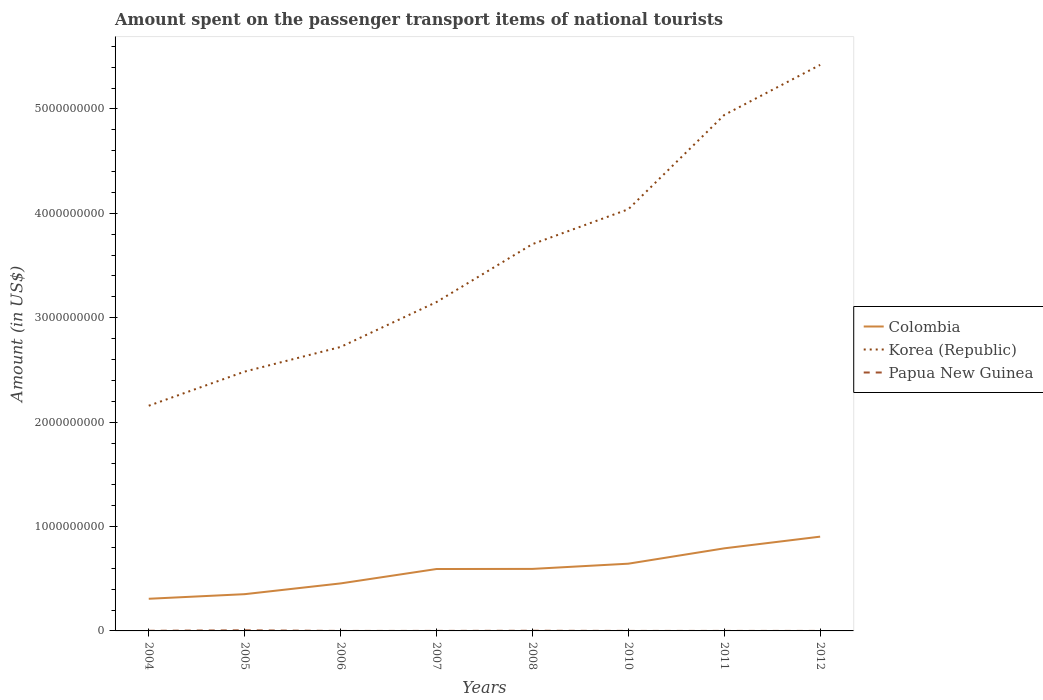How many different coloured lines are there?
Offer a terse response. 3. Is the number of lines equal to the number of legend labels?
Make the answer very short. Yes. Across all years, what is the maximum amount spent on the passenger transport items of national tourists in Korea (Republic)?
Provide a short and direct response. 2.16e+09. What is the total amount spent on the passenger transport items of national tourists in Korea (Republic) in the graph?
Make the answer very short. -1.32e+09. What is the difference between the highest and the second highest amount spent on the passenger transport items of national tourists in Colombia?
Make the answer very short. 5.95e+08. Is the amount spent on the passenger transport items of national tourists in Colombia strictly greater than the amount spent on the passenger transport items of national tourists in Korea (Republic) over the years?
Your answer should be compact. Yes. How many lines are there?
Give a very brief answer. 3. How many years are there in the graph?
Offer a very short reply. 8. What is the difference between two consecutive major ticks on the Y-axis?
Your answer should be compact. 1.00e+09. Are the values on the major ticks of Y-axis written in scientific E-notation?
Provide a succinct answer. No. How are the legend labels stacked?
Offer a terse response. Vertical. What is the title of the graph?
Offer a terse response. Amount spent on the passenger transport items of national tourists. Does "Comoros" appear as one of the legend labels in the graph?
Your answer should be very brief. No. What is the label or title of the X-axis?
Your answer should be compact. Years. What is the Amount (in US$) in Colombia in 2004?
Your answer should be very brief. 3.08e+08. What is the Amount (in US$) of Korea (Republic) in 2004?
Your answer should be compact. 2.16e+09. What is the Amount (in US$) in Papua New Guinea in 2004?
Provide a short and direct response. 1.30e+06. What is the Amount (in US$) in Colombia in 2005?
Keep it short and to the point. 3.52e+08. What is the Amount (in US$) of Korea (Republic) in 2005?
Offer a very short reply. 2.48e+09. What is the Amount (in US$) of Papua New Guinea in 2005?
Keep it short and to the point. 5.80e+06. What is the Amount (in US$) in Colombia in 2006?
Your response must be concise. 4.55e+08. What is the Amount (in US$) of Korea (Republic) in 2006?
Ensure brevity in your answer.  2.72e+09. What is the Amount (in US$) in Colombia in 2007?
Offer a very short reply. 5.93e+08. What is the Amount (in US$) of Korea (Republic) in 2007?
Your answer should be very brief. 3.15e+09. What is the Amount (in US$) of Colombia in 2008?
Your answer should be very brief. 5.94e+08. What is the Amount (in US$) of Korea (Republic) in 2008?
Ensure brevity in your answer.  3.70e+09. What is the Amount (in US$) of Papua New Guinea in 2008?
Provide a succinct answer. 1.60e+06. What is the Amount (in US$) of Colombia in 2010?
Offer a terse response. 6.44e+08. What is the Amount (in US$) of Korea (Republic) in 2010?
Keep it short and to the point. 4.04e+09. What is the Amount (in US$) of Colombia in 2011?
Keep it short and to the point. 7.91e+08. What is the Amount (in US$) in Korea (Republic) in 2011?
Your answer should be very brief. 4.94e+09. What is the Amount (in US$) in Colombia in 2012?
Offer a very short reply. 9.03e+08. What is the Amount (in US$) of Korea (Republic) in 2012?
Make the answer very short. 5.42e+09. What is the Amount (in US$) in Papua New Guinea in 2012?
Offer a terse response. 1.00e+05. Across all years, what is the maximum Amount (in US$) of Colombia?
Offer a terse response. 9.03e+08. Across all years, what is the maximum Amount (in US$) of Korea (Republic)?
Your response must be concise. 5.42e+09. Across all years, what is the maximum Amount (in US$) in Papua New Guinea?
Your answer should be compact. 5.80e+06. Across all years, what is the minimum Amount (in US$) of Colombia?
Make the answer very short. 3.08e+08. Across all years, what is the minimum Amount (in US$) of Korea (Republic)?
Provide a succinct answer. 2.16e+09. Across all years, what is the minimum Amount (in US$) of Papua New Guinea?
Provide a succinct answer. 3.00e+04. What is the total Amount (in US$) in Colombia in the graph?
Offer a terse response. 4.64e+09. What is the total Amount (in US$) in Korea (Republic) in the graph?
Offer a terse response. 2.86e+1. What is the total Amount (in US$) of Papua New Guinea in the graph?
Make the answer very short. 9.53e+06. What is the difference between the Amount (in US$) of Colombia in 2004 and that in 2005?
Your answer should be compact. -4.40e+07. What is the difference between the Amount (in US$) in Korea (Republic) in 2004 and that in 2005?
Your answer should be compact. -3.27e+08. What is the difference between the Amount (in US$) in Papua New Guinea in 2004 and that in 2005?
Your answer should be very brief. -4.50e+06. What is the difference between the Amount (in US$) in Colombia in 2004 and that in 2006?
Give a very brief answer. -1.47e+08. What is the difference between the Amount (in US$) of Korea (Republic) in 2004 and that in 2006?
Your answer should be very brief. -5.63e+08. What is the difference between the Amount (in US$) of Papua New Guinea in 2004 and that in 2006?
Make the answer very short. 1.27e+06. What is the difference between the Amount (in US$) in Colombia in 2004 and that in 2007?
Offer a very short reply. -2.85e+08. What is the difference between the Amount (in US$) of Korea (Republic) in 2004 and that in 2007?
Offer a terse response. -9.93e+08. What is the difference between the Amount (in US$) of Colombia in 2004 and that in 2008?
Offer a very short reply. -2.86e+08. What is the difference between the Amount (in US$) in Korea (Republic) in 2004 and that in 2008?
Offer a terse response. -1.55e+09. What is the difference between the Amount (in US$) in Colombia in 2004 and that in 2010?
Offer a very short reply. -3.36e+08. What is the difference between the Amount (in US$) of Korea (Republic) in 2004 and that in 2010?
Give a very brief answer. -1.88e+09. What is the difference between the Amount (in US$) of Papua New Guinea in 2004 and that in 2010?
Keep it short and to the point. 1.10e+06. What is the difference between the Amount (in US$) of Colombia in 2004 and that in 2011?
Ensure brevity in your answer.  -4.83e+08. What is the difference between the Amount (in US$) in Korea (Republic) in 2004 and that in 2011?
Ensure brevity in your answer.  -2.78e+09. What is the difference between the Amount (in US$) in Papua New Guinea in 2004 and that in 2011?
Provide a succinct answer. 1.10e+06. What is the difference between the Amount (in US$) of Colombia in 2004 and that in 2012?
Offer a very short reply. -5.95e+08. What is the difference between the Amount (in US$) in Korea (Republic) in 2004 and that in 2012?
Keep it short and to the point. -3.26e+09. What is the difference between the Amount (in US$) in Papua New Guinea in 2004 and that in 2012?
Keep it short and to the point. 1.20e+06. What is the difference between the Amount (in US$) of Colombia in 2005 and that in 2006?
Provide a short and direct response. -1.03e+08. What is the difference between the Amount (in US$) in Korea (Republic) in 2005 and that in 2006?
Keep it short and to the point. -2.36e+08. What is the difference between the Amount (in US$) of Papua New Guinea in 2005 and that in 2006?
Provide a succinct answer. 5.77e+06. What is the difference between the Amount (in US$) in Colombia in 2005 and that in 2007?
Ensure brevity in your answer.  -2.41e+08. What is the difference between the Amount (in US$) of Korea (Republic) in 2005 and that in 2007?
Keep it short and to the point. -6.66e+08. What is the difference between the Amount (in US$) of Papua New Guinea in 2005 and that in 2007?
Keep it short and to the point. 5.50e+06. What is the difference between the Amount (in US$) of Colombia in 2005 and that in 2008?
Make the answer very short. -2.42e+08. What is the difference between the Amount (in US$) in Korea (Republic) in 2005 and that in 2008?
Offer a very short reply. -1.22e+09. What is the difference between the Amount (in US$) of Papua New Guinea in 2005 and that in 2008?
Your response must be concise. 4.20e+06. What is the difference between the Amount (in US$) in Colombia in 2005 and that in 2010?
Make the answer very short. -2.92e+08. What is the difference between the Amount (in US$) in Korea (Republic) in 2005 and that in 2010?
Keep it short and to the point. -1.56e+09. What is the difference between the Amount (in US$) of Papua New Guinea in 2005 and that in 2010?
Make the answer very short. 5.60e+06. What is the difference between the Amount (in US$) in Colombia in 2005 and that in 2011?
Make the answer very short. -4.39e+08. What is the difference between the Amount (in US$) in Korea (Republic) in 2005 and that in 2011?
Your answer should be compact. -2.46e+09. What is the difference between the Amount (in US$) in Papua New Guinea in 2005 and that in 2011?
Ensure brevity in your answer.  5.60e+06. What is the difference between the Amount (in US$) of Colombia in 2005 and that in 2012?
Your answer should be compact. -5.51e+08. What is the difference between the Amount (in US$) of Korea (Republic) in 2005 and that in 2012?
Offer a very short reply. -2.94e+09. What is the difference between the Amount (in US$) in Papua New Guinea in 2005 and that in 2012?
Make the answer very short. 5.70e+06. What is the difference between the Amount (in US$) of Colombia in 2006 and that in 2007?
Make the answer very short. -1.38e+08. What is the difference between the Amount (in US$) in Korea (Republic) in 2006 and that in 2007?
Ensure brevity in your answer.  -4.30e+08. What is the difference between the Amount (in US$) in Colombia in 2006 and that in 2008?
Ensure brevity in your answer.  -1.39e+08. What is the difference between the Amount (in US$) of Korea (Republic) in 2006 and that in 2008?
Provide a succinct answer. -9.85e+08. What is the difference between the Amount (in US$) of Papua New Guinea in 2006 and that in 2008?
Make the answer very short. -1.57e+06. What is the difference between the Amount (in US$) of Colombia in 2006 and that in 2010?
Give a very brief answer. -1.89e+08. What is the difference between the Amount (in US$) in Korea (Republic) in 2006 and that in 2010?
Ensure brevity in your answer.  -1.32e+09. What is the difference between the Amount (in US$) of Papua New Guinea in 2006 and that in 2010?
Provide a short and direct response. -1.70e+05. What is the difference between the Amount (in US$) in Colombia in 2006 and that in 2011?
Give a very brief answer. -3.36e+08. What is the difference between the Amount (in US$) of Korea (Republic) in 2006 and that in 2011?
Offer a very short reply. -2.22e+09. What is the difference between the Amount (in US$) in Papua New Guinea in 2006 and that in 2011?
Your answer should be very brief. -1.70e+05. What is the difference between the Amount (in US$) in Colombia in 2006 and that in 2012?
Your response must be concise. -4.48e+08. What is the difference between the Amount (in US$) of Korea (Republic) in 2006 and that in 2012?
Provide a succinct answer. -2.70e+09. What is the difference between the Amount (in US$) in Korea (Republic) in 2007 and that in 2008?
Provide a short and direct response. -5.55e+08. What is the difference between the Amount (in US$) of Papua New Guinea in 2007 and that in 2008?
Offer a very short reply. -1.30e+06. What is the difference between the Amount (in US$) in Colombia in 2007 and that in 2010?
Provide a succinct answer. -5.10e+07. What is the difference between the Amount (in US$) in Korea (Republic) in 2007 and that in 2010?
Keep it short and to the point. -8.89e+08. What is the difference between the Amount (in US$) of Colombia in 2007 and that in 2011?
Provide a succinct answer. -1.98e+08. What is the difference between the Amount (in US$) of Korea (Republic) in 2007 and that in 2011?
Your answer should be compact. -1.79e+09. What is the difference between the Amount (in US$) of Colombia in 2007 and that in 2012?
Keep it short and to the point. -3.10e+08. What is the difference between the Amount (in US$) in Korea (Republic) in 2007 and that in 2012?
Your response must be concise. -2.27e+09. What is the difference between the Amount (in US$) in Colombia in 2008 and that in 2010?
Keep it short and to the point. -5.00e+07. What is the difference between the Amount (in US$) of Korea (Republic) in 2008 and that in 2010?
Offer a terse response. -3.34e+08. What is the difference between the Amount (in US$) of Papua New Guinea in 2008 and that in 2010?
Your answer should be very brief. 1.40e+06. What is the difference between the Amount (in US$) in Colombia in 2008 and that in 2011?
Make the answer very short. -1.97e+08. What is the difference between the Amount (in US$) in Korea (Republic) in 2008 and that in 2011?
Your answer should be very brief. -1.24e+09. What is the difference between the Amount (in US$) of Papua New Guinea in 2008 and that in 2011?
Offer a terse response. 1.40e+06. What is the difference between the Amount (in US$) in Colombia in 2008 and that in 2012?
Make the answer very short. -3.09e+08. What is the difference between the Amount (in US$) of Korea (Republic) in 2008 and that in 2012?
Your answer should be compact. -1.72e+09. What is the difference between the Amount (in US$) in Papua New Guinea in 2008 and that in 2012?
Provide a succinct answer. 1.50e+06. What is the difference between the Amount (in US$) in Colombia in 2010 and that in 2011?
Provide a succinct answer. -1.47e+08. What is the difference between the Amount (in US$) of Korea (Republic) in 2010 and that in 2011?
Provide a succinct answer. -9.03e+08. What is the difference between the Amount (in US$) of Papua New Guinea in 2010 and that in 2011?
Provide a short and direct response. 0. What is the difference between the Amount (in US$) in Colombia in 2010 and that in 2012?
Offer a terse response. -2.59e+08. What is the difference between the Amount (in US$) in Korea (Republic) in 2010 and that in 2012?
Provide a succinct answer. -1.38e+09. What is the difference between the Amount (in US$) of Colombia in 2011 and that in 2012?
Ensure brevity in your answer.  -1.12e+08. What is the difference between the Amount (in US$) of Korea (Republic) in 2011 and that in 2012?
Provide a short and direct response. -4.80e+08. What is the difference between the Amount (in US$) in Papua New Guinea in 2011 and that in 2012?
Give a very brief answer. 1.00e+05. What is the difference between the Amount (in US$) in Colombia in 2004 and the Amount (in US$) in Korea (Republic) in 2005?
Offer a terse response. -2.18e+09. What is the difference between the Amount (in US$) of Colombia in 2004 and the Amount (in US$) of Papua New Guinea in 2005?
Offer a terse response. 3.02e+08. What is the difference between the Amount (in US$) of Korea (Republic) in 2004 and the Amount (in US$) of Papua New Guinea in 2005?
Make the answer very short. 2.15e+09. What is the difference between the Amount (in US$) of Colombia in 2004 and the Amount (in US$) of Korea (Republic) in 2006?
Provide a short and direct response. -2.41e+09. What is the difference between the Amount (in US$) in Colombia in 2004 and the Amount (in US$) in Papua New Guinea in 2006?
Provide a short and direct response. 3.08e+08. What is the difference between the Amount (in US$) of Korea (Republic) in 2004 and the Amount (in US$) of Papua New Guinea in 2006?
Ensure brevity in your answer.  2.16e+09. What is the difference between the Amount (in US$) in Colombia in 2004 and the Amount (in US$) in Korea (Republic) in 2007?
Give a very brief answer. -2.84e+09. What is the difference between the Amount (in US$) in Colombia in 2004 and the Amount (in US$) in Papua New Guinea in 2007?
Keep it short and to the point. 3.08e+08. What is the difference between the Amount (in US$) of Korea (Republic) in 2004 and the Amount (in US$) of Papua New Guinea in 2007?
Your answer should be very brief. 2.16e+09. What is the difference between the Amount (in US$) in Colombia in 2004 and the Amount (in US$) in Korea (Republic) in 2008?
Give a very brief answer. -3.40e+09. What is the difference between the Amount (in US$) in Colombia in 2004 and the Amount (in US$) in Papua New Guinea in 2008?
Offer a terse response. 3.06e+08. What is the difference between the Amount (in US$) in Korea (Republic) in 2004 and the Amount (in US$) in Papua New Guinea in 2008?
Give a very brief answer. 2.16e+09. What is the difference between the Amount (in US$) in Colombia in 2004 and the Amount (in US$) in Korea (Republic) in 2010?
Offer a very short reply. -3.73e+09. What is the difference between the Amount (in US$) in Colombia in 2004 and the Amount (in US$) in Papua New Guinea in 2010?
Your response must be concise. 3.08e+08. What is the difference between the Amount (in US$) in Korea (Republic) in 2004 and the Amount (in US$) in Papua New Guinea in 2010?
Provide a succinct answer. 2.16e+09. What is the difference between the Amount (in US$) in Colombia in 2004 and the Amount (in US$) in Korea (Republic) in 2011?
Ensure brevity in your answer.  -4.63e+09. What is the difference between the Amount (in US$) in Colombia in 2004 and the Amount (in US$) in Papua New Guinea in 2011?
Your answer should be compact. 3.08e+08. What is the difference between the Amount (in US$) of Korea (Republic) in 2004 and the Amount (in US$) of Papua New Guinea in 2011?
Your response must be concise. 2.16e+09. What is the difference between the Amount (in US$) in Colombia in 2004 and the Amount (in US$) in Korea (Republic) in 2012?
Offer a very short reply. -5.11e+09. What is the difference between the Amount (in US$) of Colombia in 2004 and the Amount (in US$) of Papua New Guinea in 2012?
Your answer should be very brief. 3.08e+08. What is the difference between the Amount (in US$) in Korea (Republic) in 2004 and the Amount (in US$) in Papua New Guinea in 2012?
Your answer should be very brief. 2.16e+09. What is the difference between the Amount (in US$) in Colombia in 2005 and the Amount (in US$) in Korea (Republic) in 2006?
Offer a terse response. -2.37e+09. What is the difference between the Amount (in US$) of Colombia in 2005 and the Amount (in US$) of Papua New Guinea in 2006?
Provide a succinct answer. 3.52e+08. What is the difference between the Amount (in US$) of Korea (Republic) in 2005 and the Amount (in US$) of Papua New Guinea in 2006?
Ensure brevity in your answer.  2.48e+09. What is the difference between the Amount (in US$) in Colombia in 2005 and the Amount (in US$) in Korea (Republic) in 2007?
Your answer should be very brief. -2.80e+09. What is the difference between the Amount (in US$) of Colombia in 2005 and the Amount (in US$) of Papua New Guinea in 2007?
Ensure brevity in your answer.  3.52e+08. What is the difference between the Amount (in US$) in Korea (Republic) in 2005 and the Amount (in US$) in Papua New Guinea in 2007?
Your response must be concise. 2.48e+09. What is the difference between the Amount (in US$) of Colombia in 2005 and the Amount (in US$) of Korea (Republic) in 2008?
Offer a very short reply. -3.35e+09. What is the difference between the Amount (in US$) in Colombia in 2005 and the Amount (in US$) in Papua New Guinea in 2008?
Keep it short and to the point. 3.50e+08. What is the difference between the Amount (in US$) in Korea (Republic) in 2005 and the Amount (in US$) in Papua New Guinea in 2008?
Offer a terse response. 2.48e+09. What is the difference between the Amount (in US$) of Colombia in 2005 and the Amount (in US$) of Korea (Republic) in 2010?
Keep it short and to the point. -3.69e+09. What is the difference between the Amount (in US$) in Colombia in 2005 and the Amount (in US$) in Papua New Guinea in 2010?
Your answer should be very brief. 3.52e+08. What is the difference between the Amount (in US$) of Korea (Republic) in 2005 and the Amount (in US$) of Papua New Guinea in 2010?
Your answer should be compact. 2.48e+09. What is the difference between the Amount (in US$) in Colombia in 2005 and the Amount (in US$) in Korea (Republic) in 2011?
Provide a short and direct response. -4.59e+09. What is the difference between the Amount (in US$) of Colombia in 2005 and the Amount (in US$) of Papua New Guinea in 2011?
Provide a succinct answer. 3.52e+08. What is the difference between the Amount (in US$) in Korea (Republic) in 2005 and the Amount (in US$) in Papua New Guinea in 2011?
Keep it short and to the point. 2.48e+09. What is the difference between the Amount (in US$) in Colombia in 2005 and the Amount (in US$) in Korea (Republic) in 2012?
Provide a short and direct response. -5.07e+09. What is the difference between the Amount (in US$) in Colombia in 2005 and the Amount (in US$) in Papua New Guinea in 2012?
Your response must be concise. 3.52e+08. What is the difference between the Amount (in US$) of Korea (Republic) in 2005 and the Amount (in US$) of Papua New Guinea in 2012?
Your answer should be compact. 2.48e+09. What is the difference between the Amount (in US$) of Colombia in 2006 and the Amount (in US$) of Korea (Republic) in 2007?
Make the answer very short. -2.70e+09. What is the difference between the Amount (in US$) of Colombia in 2006 and the Amount (in US$) of Papua New Guinea in 2007?
Make the answer very short. 4.55e+08. What is the difference between the Amount (in US$) of Korea (Republic) in 2006 and the Amount (in US$) of Papua New Guinea in 2007?
Ensure brevity in your answer.  2.72e+09. What is the difference between the Amount (in US$) of Colombia in 2006 and the Amount (in US$) of Korea (Republic) in 2008?
Offer a terse response. -3.25e+09. What is the difference between the Amount (in US$) in Colombia in 2006 and the Amount (in US$) in Papua New Guinea in 2008?
Ensure brevity in your answer.  4.53e+08. What is the difference between the Amount (in US$) in Korea (Republic) in 2006 and the Amount (in US$) in Papua New Guinea in 2008?
Give a very brief answer. 2.72e+09. What is the difference between the Amount (in US$) of Colombia in 2006 and the Amount (in US$) of Korea (Republic) in 2010?
Offer a very short reply. -3.58e+09. What is the difference between the Amount (in US$) of Colombia in 2006 and the Amount (in US$) of Papua New Guinea in 2010?
Keep it short and to the point. 4.55e+08. What is the difference between the Amount (in US$) of Korea (Republic) in 2006 and the Amount (in US$) of Papua New Guinea in 2010?
Offer a terse response. 2.72e+09. What is the difference between the Amount (in US$) in Colombia in 2006 and the Amount (in US$) in Korea (Republic) in 2011?
Keep it short and to the point. -4.49e+09. What is the difference between the Amount (in US$) of Colombia in 2006 and the Amount (in US$) of Papua New Guinea in 2011?
Give a very brief answer. 4.55e+08. What is the difference between the Amount (in US$) of Korea (Republic) in 2006 and the Amount (in US$) of Papua New Guinea in 2011?
Offer a terse response. 2.72e+09. What is the difference between the Amount (in US$) of Colombia in 2006 and the Amount (in US$) of Korea (Republic) in 2012?
Ensure brevity in your answer.  -4.97e+09. What is the difference between the Amount (in US$) of Colombia in 2006 and the Amount (in US$) of Papua New Guinea in 2012?
Ensure brevity in your answer.  4.55e+08. What is the difference between the Amount (in US$) in Korea (Republic) in 2006 and the Amount (in US$) in Papua New Guinea in 2012?
Ensure brevity in your answer.  2.72e+09. What is the difference between the Amount (in US$) in Colombia in 2007 and the Amount (in US$) in Korea (Republic) in 2008?
Provide a succinct answer. -3.11e+09. What is the difference between the Amount (in US$) of Colombia in 2007 and the Amount (in US$) of Papua New Guinea in 2008?
Make the answer very short. 5.91e+08. What is the difference between the Amount (in US$) in Korea (Republic) in 2007 and the Amount (in US$) in Papua New Guinea in 2008?
Offer a terse response. 3.15e+09. What is the difference between the Amount (in US$) in Colombia in 2007 and the Amount (in US$) in Korea (Republic) in 2010?
Make the answer very short. -3.45e+09. What is the difference between the Amount (in US$) in Colombia in 2007 and the Amount (in US$) in Papua New Guinea in 2010?
Ensure brevity in your answer.  5.93e+08. What is the difference between the Amount (in US$) in Korea (Republic) in 2007 and the Amount (in US$) in Papua New Guinea in 2010?
Your answer should be very brief. 3.15e+09. What is the difference between the Amount (in US$) of Colombia in 2007 and the Amount (in US$) of Korea (Republic) in 2011?
Your answer should be compact. -4.35e+09. What is the difference between the Amount (in US$) of Colombia in 2007 and the Amount (in US$) of Papua New Guinea in 2011?
Make the answer very short. 5.93e+08. What is the difference between the Amount (in US$) in Korea (Republic) in 2007 and the Amount (in US$) in Papua New Guinea in 2011?
Provide a succinct answer. 3.15e+09. What is the difference between the Amount (in US$) in Colombia in 2007 and the Amount (in US$) in Korea (Republic) in 2012?
Your response must be concise. -4.83e+09. What is the difference between the Amount (in US$) of Colombia in 2007 and the Amount (in US$) of Papua New Guinea in 2012?
Your response must be concise. 5.93e+08. What is the difference between the Amount (in US$) in Korea (Republic) in 2007 and the Amount (in US$) in Papua New Guinea in 2012?
Give a very brief answer. 3.15e+09. What is the difference between the Amount (in US$) in Colombia in 2008 and the Amount (in US$) in Korea (Republic) in 2010?
Ensure brevity in your answer.  -3.44e+09. What is the difference between the Amount (in US$) in Colombia in 2008 and the Amount (in US$) in Papua New Guinea in 2010?
Your answer should be very brief. 5.94e+08. What is the difference between the Amount (in US$) of Korea (Republic) in 2008 and the Amount (in US$) of Papua New Guinea in 2010?
Your response must be concise. 3.70e+09. What is the difference between the Amount (in US$) of Colombia in 2008 and the Amount (in US$) of Korea (Republic) in 2011?
Provide a succinct answer. -4.35e+09. What is the difference between the Amount (in US$) in Colombia in 2008 and the Amount (in US$) in Papua New Guinea in 2011?
Keep it short and to the point. 5.94e+08. What is the difference between the Amount (in US$) in Korea (Republic) in 2008 and the Amount (in US$) in Papua New Guinea in 2011?
Make the answer very short. 3.70e+09. What is the difference between the Amount (in US$) in Colombia in 2008 and the Amount (in US$) in Korea (Republic) in 2012?
Your answer should be compact. -4.83e+09. What is the difference between the Amount (in US$) in Colombia in 2008 and the Amount (in US$) in Papua New Guinea in 2012?
Provide a short and direct response. 5.94e+08. What is the difference between the Amount (in US$) of Korea (Republic) in 2008 and the Amount (in US$) of Papua New Guinea in 2012?
Your response must be concise. 3.70e+09. What is the difference between the Amount (in US$) in Colombia in 2010 and the Amount (in US$) in Korea (Republic) in 2011?
Provide a succinct answer. -4.30e+09. What is the difference between the Amount (in US$) in Colombia in 2010 and the Amount (in US$) in Papua New Guinea in 2011?
Offer a very short reply. 6.44e+08. What is the difference between the Amount (in US$) of Korea (Republic) in 2010 and the Amount (in US$) of Papua New Guinea in 2011?
Offer a terse response. 4.04e+09. What is the difference between the Amount (in US$) of Colombia in 2010 and the Amount (in US$) of Korea (Republic) in 2012?
Provide a short and direct response. -4.78e+09. What is the difference between the Amount (in US$) of Colombia in 2010 and the Amount (in US$) of Papua New Guinea in 2012?
Offer a terse response. 6.44e+08. What is the difference between the Amount (in US$) in Korea (Republic) in 2010 and the Amount (in US$) in Papua New Guinea in 2012?
Offer a very short reply. 4.04e+09. What is the difference between the Amount (in US$) in Colombia in 2011 and the Amount (in US$) in Korea (Republic) in 2012?
Offer a terse response. -4.63e+09. What is the difference between the Amount (in US$) in Colombia in 2011 and the Amount (in US$) in Papua New Guinea in 2012?
Make the answer very short. 7.91e+08. What is the difference between the Amount (in US$) in Korea (Republic) in 2011 and the Amount (in US$) in Papua New Guinea in 2012?
Provide a succinct answer. 4.94e+09. What is the average Amount (in US$) of Colombia per year?
Provide a short and direct response. 5.80e+08. What is the average Amount (in US$) in Korea (Republic) per year?
Your answer should be very brief. 3.58e+09. What is the average Amount (in US$) in Papua New Guinea per year?
Your response must be concise. 1.19e+06. In the year 2004, what is the difference between the Amount (in US$) in Colombia and Amount (in US$) in Korea (Republic)?
Offer a very short reply. -1.85e+09. In the year 2004, what is the difference between the Amount (in US$) in Colombia and Amount (in US$) in Papua New Guinea?
Make the answer very short. 3.07e+08. In the year 2004, what is the difference between the Amount (in US$) of Korea (Republic) and Amount (in US$) of Papua New Guinea?
Your answer should be compact. 2.16e+09. In the year 2005, what is the difference between the Amount (in US$) of Colombia and Amount (in US$) of Korea (Republic)?
Provide a succinct answer. -2.13e+09. In the year 2005, what is the difference between the Amount (in US$) of Colombia and Amount (in US$) of Papua New Guinea?
Offer a terse response. 3.46e+08. In the year 2005, what is the difference between the Amount (in US$) in Korea (Republic) and Amount (in US$) in Papua New Guinea?
Your response must be concise. 2.48e+09. In the year 2006, what is the difference between the Amount (in US$) in Colombia and Amount (in US$) in Korea (Republic)?
Your response must be concise. -2.26e+09. In the year 2006, what is the difference between the Amount (in US$) in Colombia and Amount (in US$) in Papua New Guinea?
Your response must be concise. 4.55e+08. In the year 2006, what is the difference between the Amount (in US$) in Korea (Republic) and Amount (in US$) in Papua New Guinea?
Your answer should be compact. 2.72e+09. In the year 2007, what is the difference between the Amount (in US$) in Colombia and Amount (in US$) in Korea (Republic)?
Keep it short and to the point. -2.56e+09. In the year 2007, what is the difference between the Amount (in US$) of Colombia and Amount (in US$) of Papua New Guinea?
Provide a succinct answer. 5.93e+08. In the year 2007, what is the difference between the Amount (in US$) in Korea (Republic) and Amount (in US$) in Papua New Guinea?
Your answer should be very brief. 3.15e+09. In the year 2008, what is the difference between the Amount (in US$) of Colombia and Amount (in US$) of Korea (Republic)?
Give a very brief answer. -3.11e+09. In the year 2008, what is the difference between the Amount (in US$) in Colombia and Amount (in US$) in Papua New Guinea?
Make the answer very short. 5.92e+08. In the year 2008, what is the difference between the Amount (in US$) of Korea (Republic) and Amount (in US$) of Papua New Guinea?
Keep it short and to the point. 3.70e+09. In the year 2010, what is the difference between the Amount (in US$) of Colombia and Amount (in US$) of Korea (Republic)?
Offer a terse response. -3.40e+09. In the year 2010, what is the difference between the Amount (in US$) in Colombia and Amount (in US$) in Papua New Guinea?
Your answer should be very brief. 6.44e+08. In the year 2010, what is the difference between the Amount (in US$) in Korea (Republic) and Amount (in US$) in Papua New Guinea?
Provide a succinct answer. 4.04e+09. In the year 2011, what is the difference between the Amount (in US$) in Colombia and Amount (in US$) in Korea (Republic)?
Your answer should be compact. -4.15e+09. In the year 2011, what is the difference between the Amount (in US$) in Colombia and Amount (in US$) in Papua New Guinea?
Keep it short and to the point. 7.91e+08. In the year 2011, what is the difference between the Amount (in US$) of Korea (Republic) and Amount (in US$) of Papua New Guinea?
Your response must be concise. 4.94e+09. In the year 2012, what is the difference between the Amount (in US$) of Colombia and Amount (in US$) of Korea (Republic)?
Ensure brevity in your answer.  -4.52e+09. In the year 2012, what is the difference between the Amount (in US$) of Colombia and Amount (in US$) of Papua New Guinea?
Offer a very short reply. 9.03e+08. In the year 2012, what is the difference between the Amount (in US$) of Korea (Republic) and Amount (in US$) of Papua New Guinea?
Provide a short and direct response. 5.42e+09. What is the ratio of the Amount (in US$) of Korea (Republic) in 2004 to that in 2005?
Provide a succinct answer. 0.87. What is the ratio of the Amount (in US$) of Papua New Guinea in 2004 to that in 2005?
Provide a succinct answer. 0.22. What is the ratio of the Amount (in US$) of Colombia in 2004 to that in 2006?
Give a very brief answer. 0.68. What is the ratio of the Amount (in US$) of Korea (Republic) in 2004 to that in 2006?
Your response must be concise. 0.79. What is the ratio of the Amount (in US$) in Papua New Guinea in 2004 to that in 2006?
Your answer should be very brief. 43.33. What is the ratio of the Amount (in US$) in Colombia in 2004 to that in 2007?
Keep it short and to the point. 0.52. What is the ratio of the Amount (in US$) in Korea (Republic) in 2004 to that in 2007?
Ensure brevity in your answer.  0.68. What is the ratio of the Amount (in US$) in Papua New Guinea in 2004 to that in 2007?
Offer a very short reply. 4.33. What is the ratio of the Amount (in US$) in Colombia in 2004 to that in 2008?
Your response must be concise. 0.52. What is the ratio of the Amount (in US$) in Korea (Republic) in 2004 to that in 2008?
Offer a terse response. 0.58. What is the ratio of the Amount (in US$) in Papua New Guinea in 2004 to that in 2008?
Offer a terse response. 0.81. What is the ratio of the Amount (in US$) of Colombia in 2004 to that in 2010?
Your response must be concise. 0.48. What is the ratio of the Amount (in US$) of Korea (Republic) in 2004 to that in 2010?
Your answer should be compact. 0.53. What is the ratio of the Amount (in US$) of Colombia in 2004 to that in 2011?
Provide a succinct answer. 0.39. What is the ratio of the Amount (in US$) in Korea (Republic) in 2004 to that in 2011?
Provide a short and direct response. 0.44. What is the ratio of the Amount (in US$) in Papua New Guinea in 2004 to that in 2011?
Keep it short and to the point. 6.5. What is the ratio of the Amount (in US$) in Colombia in 2004 to that in 2012?
Provide a succinct answer. 0.34. What is the ratio of the Amount (in US$) in Korea (Republic) in 2004 to that in 2012?
Your response must be concise. 0.4. What is the ratio of the Amount (in US$) in Papua New Guinea in 2004 to that in 2012?
Ensure brevity in your answer.  13. What is the ratio of the Amount (in US$) in Colombia in 2005 to that in 2006?
Your answer should be compact. 0.77. What is the ratio of the Amount (in US$) in Korea (Republic) in 2005 to that in 2006?
Make the answer very short. 0.91. What is the ratio of the Amount (in US$) of Papua New Guinea in 2005 to that in 2006?
Ensure brevity in your answer.  193.33. What is the ratio of the Amount (in US$) in Colombia in 2005 to that in 2007?
Make the answer very short. 0.59. What is the ratio of the Amount (in US$) in Korea (Republic) in 2005 to that in 2007?
Your answer should be very brief. 0.79. What is the ratio of the Amount (in US$) in Papua New Guinea in 2005 to that in 2007?
Provide a succinct answer. 19.33. What is the ratio of the Amount (in US$) in Colombia in 2005 to that in 2008?
Give a very brief answer. 0.59. What is the ratio of the Amount (in US$) of Korea (Republic) in 2005 to that in 2008?
Your response must be concise. 0.67. What is the ratio of the Amount (in US$) of Papua New Guinea in 2005 to that in 2008?
Ensure brevity in your answer.  3.62. What is the ratio of the Amount (in US$) of Colombia in 2005 to that in 2010?
Keep it short and to the point. 0.55. What is the ratio of the Amount (in US$) in Korea (Republic) in 2005 to that in 2010?
Provide a short and direct response. 0.61. What is the ratio of the Amount (in US$) in Papua New Guinea in 2005 to that in 2010?
Make the answer very short. 29. What is the ratio of the Amount (in US$) in Colombia in 2005 to that in 2011?
Offer a very short reply. 0.45. What is the ratio of the Amount (in US$) of Korea (Republic) in 2005 to that in 2011?
Give a very brief answer. 0.5. What is the ratio of the Amount (in US$) of Papua New Guinea in 2005 to that in 2011?
Provide a succinct answer. 29. What is the ratio of the Amount (in US$) in Colombia in 2005 to that in 2012?
Offer a terse response. 0.39. What is the ratio of the Amount (in US$) of Korea (Republic) in 2005 to that in 2012?
Offer a terse response. 0.46. What is the ratio of the Amount (in US$) in Papua New Guinea in 2005 to that in 2012?
Ensure brevity in your answer.  58. What is the ratio of the Amount (in US$) in Colombia in 2006 to that in 2007?
Provide a succinct answer. 0.77. What is the ratio of the Amount (in US$) in Korea (Republic) in 2006 to that in 2007?
Your response must be concise. 0.86. What is the ratio of the Amount (in US$) in Colombia in 2006 to that in 2008?
Keep it short and to the point. 0.77. What is the ratio of the Amount (in US$) in Korea (Republic) in 2006 to that in 2008?
Offer a terse response. 0.73. What is the ratio of the Amount (in US$) of Papua New Guinea in 2006 to that in 2008?
Offer a terse response. 0.02. What is the ratio of the Amount (in US$) in Colombia in 2006 to that in 2010?
Your answer should be very brief. 0.71. What is the ratio of the Amount (in US$) in Korea (Republic) in 2006 to that in 2010?
Offer a very short reply. 0.67. What is the ratio of the Amount (in US$) in Papua New Guinea in 2006 to that in 2010?
Provide a short and direct response. 0.15. What is the ratio of the Amount (in US$) of Colombia in 2006 to that in 2011?
Your answer should be very brief. 0.58. What is the ratio of the Amount (in US$) of Korea (Republic) in 2006 to that in 2011?
Ensure brevity in your answer.  0.55. What is the ratio of the Amount (in US$) of Colombia in 2006 to that in 2012?
Provide a short and direct response. 0.5. What is the ratio of the Amount (in US$) in Korea (Republic) in 2006 to that in 2012?
Provide a short and direct response. 0.5. What is the ratio of the Amount (in US$) in Papua New Guinea in 2006 to that in 2012?
Make the answer very short. 0.3. What is the ratio of the Amount (in US$) of Korea (Republic) in 2007 to that in 2008?
Your answer should be compact. 0.85. What is the ratio of the Amount (in US$) of Papua New Guinea in 2007 to that in 2008?
Ensure brevity in your answer.  0.19. What is the ratio of the Amount (in US$) in Colombia in 2007 to that in 2010?
Provide a succinct answer. 0.92. What is the ratio of the Amount (in US$) of Korea (Republic) in 2007 to that in 2010?
Make the answer very short. 0.78. What is the ratio of the Amount (in US$) of Colombia in 2007 to that in 2011?
Offer a terse response. 0.75. What is the ratio of the Amount (in US$) in Korea (Republic) in 2007 to that in 2011?
Provide a succinct answer. 0.64. What is the ratio of the Amount (in US$) of Colombia in 2007 to that in 2012?
Give a very brief answer. 0.66. What is the ratio of the Amount (in US$) of Korea (Republic) in 2007 to that in 2012?
Keep it short and to the point. 0.58. What is the ratio of the Amount (in US$) of Colombia in 2008 to that in 2010?
Ensure brevity in your answer.  0.92. What is the ratio of the Amount (in US$) in Korea (Republic) in 2008 to that in 2010?
Keep it short and to the point. 0.92. What is the ratio of the Amount (in US$) of Colombia in 2008 to that in 2011?
Provide a succinct answer. 0.75. What is the ratio of the Amount (in US$) of Korea (Republic) in 2008 to that in 2011?
Keep it short and to the point. 0.75. What is the ratio of the Amount (in US$) in Colombia in 2008 to that in 2012?
Keep it short and to the point. 0.66. What is the ratio of the Amount (in US$) of Korea (Republic) in 2008 to that in 2012?
Provide a short and direct response. 0.68. What is the ratio of the Amount (in US$) in Papua New Guinea in 2008 to that in 2012?
Offer a very short reply. 16. What is the ratio of the Amount (in US$) of Colombia in 2010 to that in 2011?
Give a very brief answer. 0.81. What is the ratio of the Amount (in US$) of Korea (Republic) in 2010 to that in 2011?
Provide a succinct answer. 0.82. What is the ratio of the Amount (in US$) of Papua New Guinea in 2010 to that in 2011?
Offer a very short reply. 1. What is the ratio of the Amount (in US$) in Colombia in 2010 to that in 2012?
Provide a short and direct response. 0.71. What is the ratio of the Amount (in US$) of Korea (Republic) in 2010 to that in 2012?
Your answer should be compact. 0.74. What is the ratio of the Amount (in US$) in Colombia in 2011 to that in 2012?
Your response must be concise. 0.88. What is the ratio of the Amount (in US$) of Korea (Republic) in 2011 to that in 2012?
Give a very brief answer. 0.91. What is the difference between the highest and the second highest Amount (in US$) in Colombia?
Make the answer very short. 1.12e+08. What is the difference between the highest and the second highest Amount (in US$) in Korea (Republic)?
Your response must be concise. 4.80e+08. What is the difference between the highest and the second highest Amount (in US$) in Papua New Guinea?
Provide a succinct answer. 4.20e+06. What is the difference between the highest and the lowest Amount (in US$) in Colombia?
Give a very brief answer. 5.95e+08. What is the difference between the highest and the lowest Amount (in US$) of Korea (Republic)?
Offer a terse response. 3.26e+09. What is the difference between the highest and the lowest Amount (in US$) in Papua New Guinea?
Give a very brief answer. 5.77e+06. 